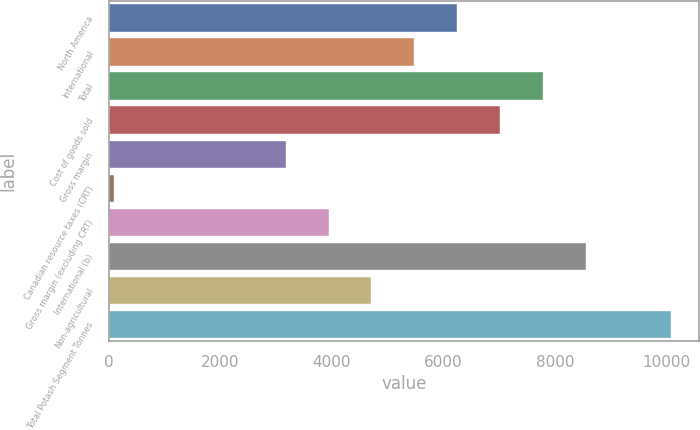Convert chart. <chart><loc_0><loc_0><loc_500><loc_500><bar_chart><fcel>North America<fcel>International<fcel>Total<fcel>Cost of goods sold<fcel>Gross margin<fcel>Canadian resource taxes (CRT)<fcel>Gross margin (excluding CRT)<fcel>International (b)<fcel>Non-agricultural<fcel>Total Potash Segment Tonnes<nl><fcel>6242.62<fcel>5474.93<fcel>7778<fcel>7010.31<fcel>3171.86<fcel>101.1<fcel>3939.55<fcel>8545.69<fcel>4707.24<fcel>10081.1<nl></chart> 